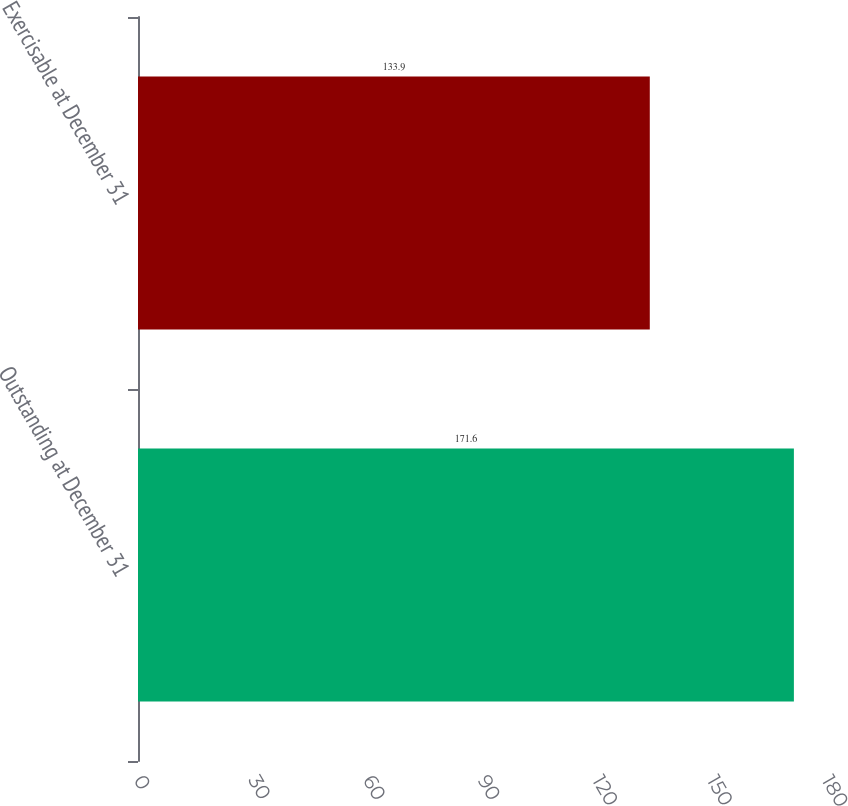<chart> <loc_0><loc_0><loc_500><loc_500><bar_chart><fcel>Outstanding at December 31<fcel>Exercisable at December 31<nl><fcel>171.6<fcel>133.9<nl></chart> 